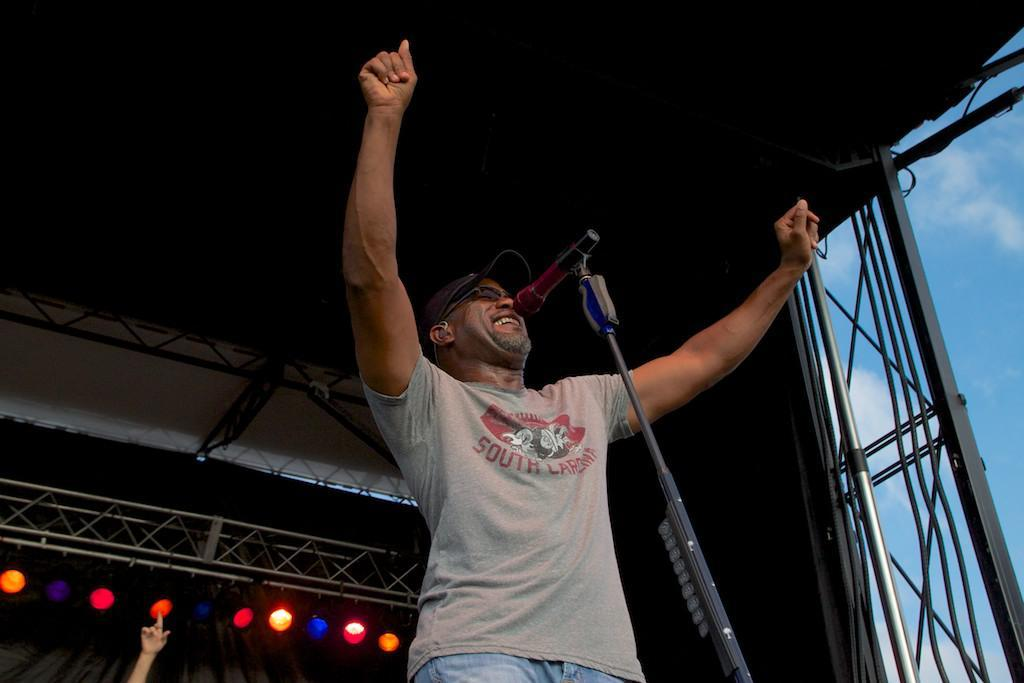What is the person on the stage doing? The person is holding a microphone. What can be seen in the background of the image? There is stage lighting visible in the background. Can you describe any other details about the person on the stage? There is a person's hand in the image. What type of flag is being waved by the person on the stage? There is no flag visible in the image; the person is holding a microphone. What boundary is being crossed by the person on the stage? There is no mention of a boundary in the image; it simply shows a person standing on a stage with a microphone. 